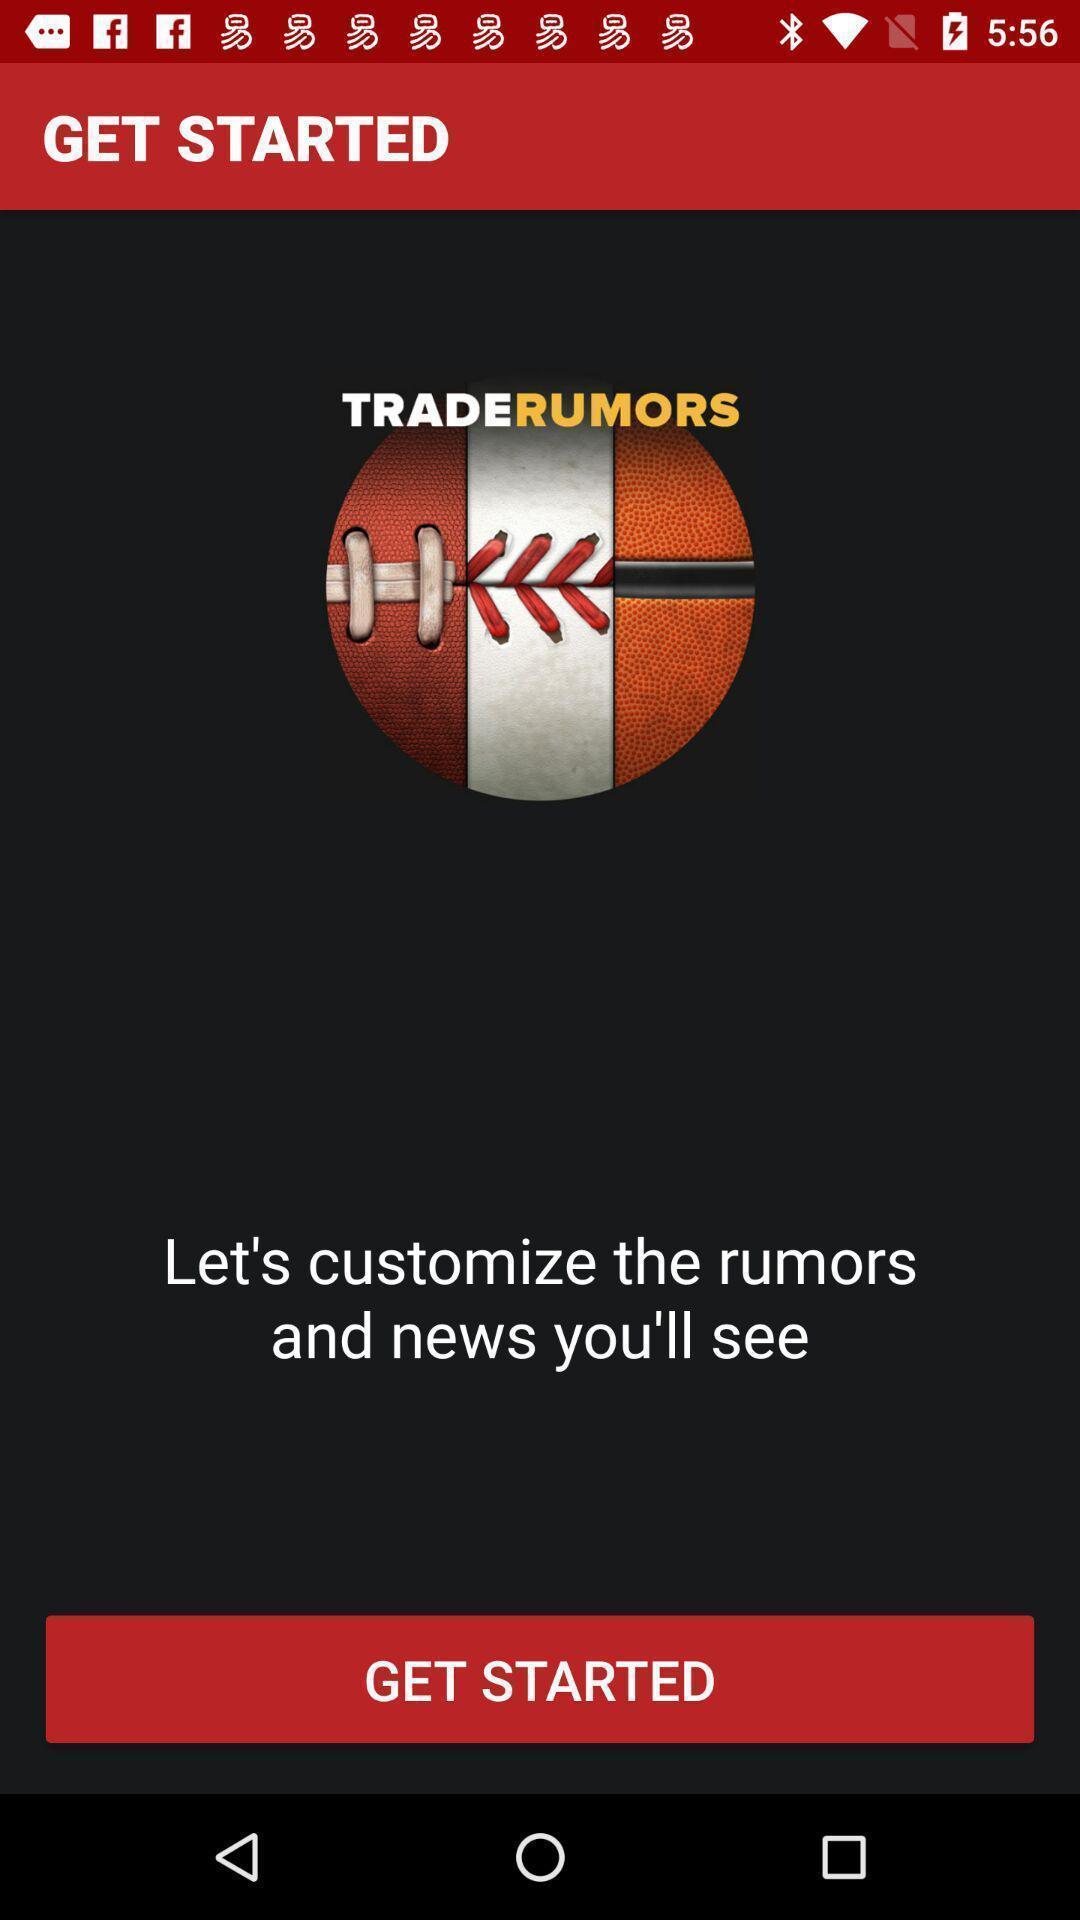Describe this image in words. Start page. 